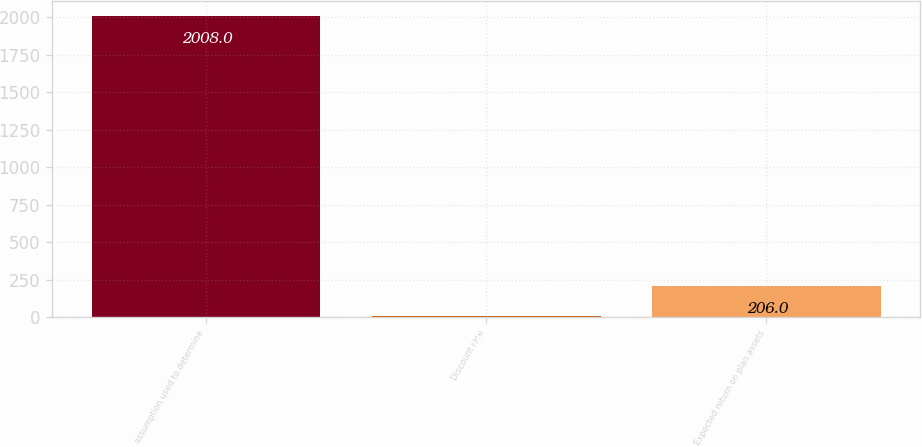<chart> <loc_0><loc_0><loc_500><loc_500><bar_chart><fcel>assumption used to determine<fcel>Discount rate<fcel>Expected return on plan assets<nl><fcel>2008<fcel>5.78<fcel>206<nl></chart> 